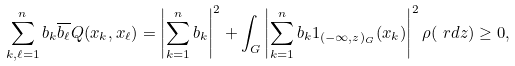Convert formula to latex. <formula><loc_0><loc_0><loc_500><loc_500>\sum _ { k , \ell = 1 } ^ { n } b _ { k } \overline { b _ { \ell } } Q ( x _ { k } , x _ { \ell } ) = \left | \sum _ { k = 1 } ^ { n } b _ { k } \right | ^ { 2 } + \int _ { G } \left | \sum _ { k = 1 } ^ { n } b _ { k } 1 _ { ( - \infty , z ) _ { G } } ( x _ { k } ) \right | ^ { 2 } \rho ( \ r d z ) \geq 0 ,</formula> 